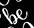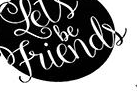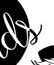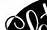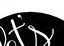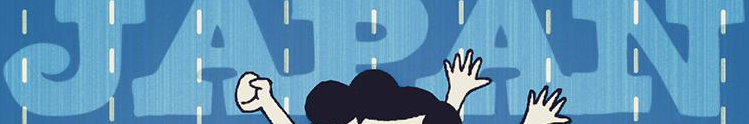Read the text from these images in sequence, separated by a semicolon. be; Friends; ds; ##; t's; JAPAN 